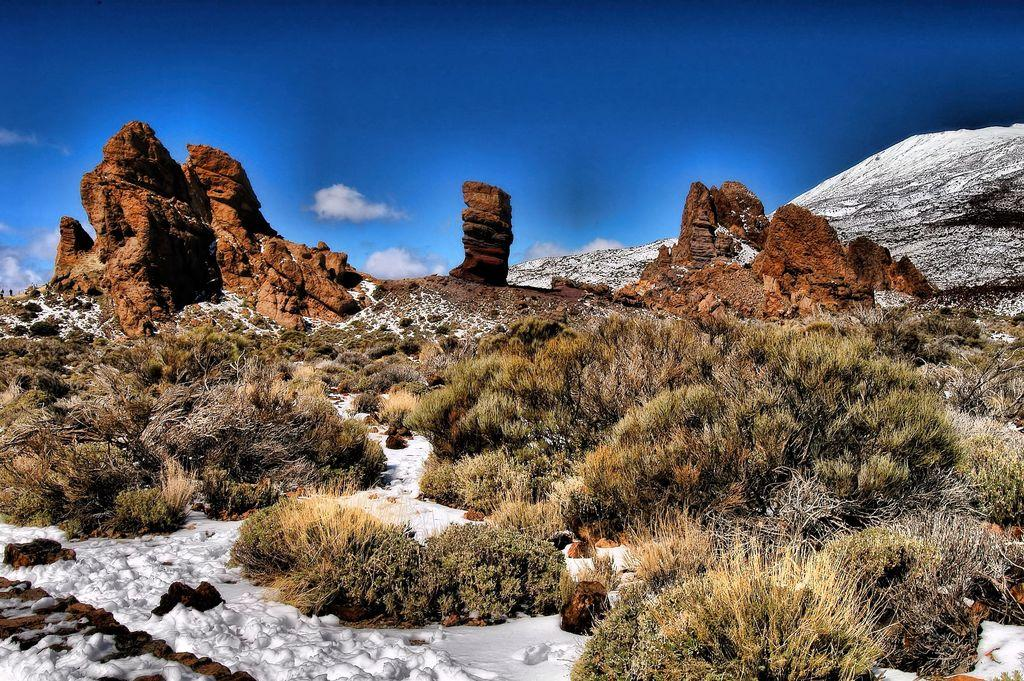What type of weather is depicted in the image? There is snow in the image, indicating cold weather. What type of terrain is visible in the image? There is grass and stones in the image, suggesting a mix of vegetation and rocky areas. What can be seen in the background of the image? There are mountains and the sky visible in the background of the image. What is the condition of the sky in the image? The sky is visible in the background of the image, and clouds are present. What type of bottle is being offered in the image? There is no bottle present in the image. What type of prose is being recited in the image? There is no recitation of prose in the image. 